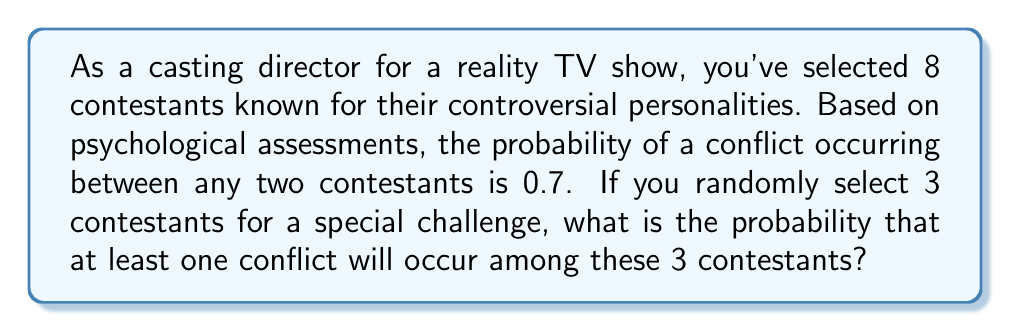Can you answer this question? To solve this problem, we'll use the complement method:

1) First, let's calculate the probability that no conflicts occur among the 3 selected contestants.

2) For no conflicts to occur, all three pairs of contestants must not have a conflict.

3) The probability of no conflict between any two contestants is $1 - 0.7 = 0.3$.

4) There are $\binom{3}{2} = 3$ possible pairs among 3 contestants.

5) The probability of no conflicts among all 3 contestants is:

   $$(0.3)^3 = 0.027$$

6) Therefore, the probability of at least one conflict is the complement of this:

   $$1 - (0.3)^3 = 1 - 0.027 = 0.973$$

7) We can also express this as a percentage:

   $$0.973 \times 100\% = 97.3\%$$
Answer: The probability that at least one conflict will occur among the 3 randomly selected contestants is 0.973 or 97.3%. 